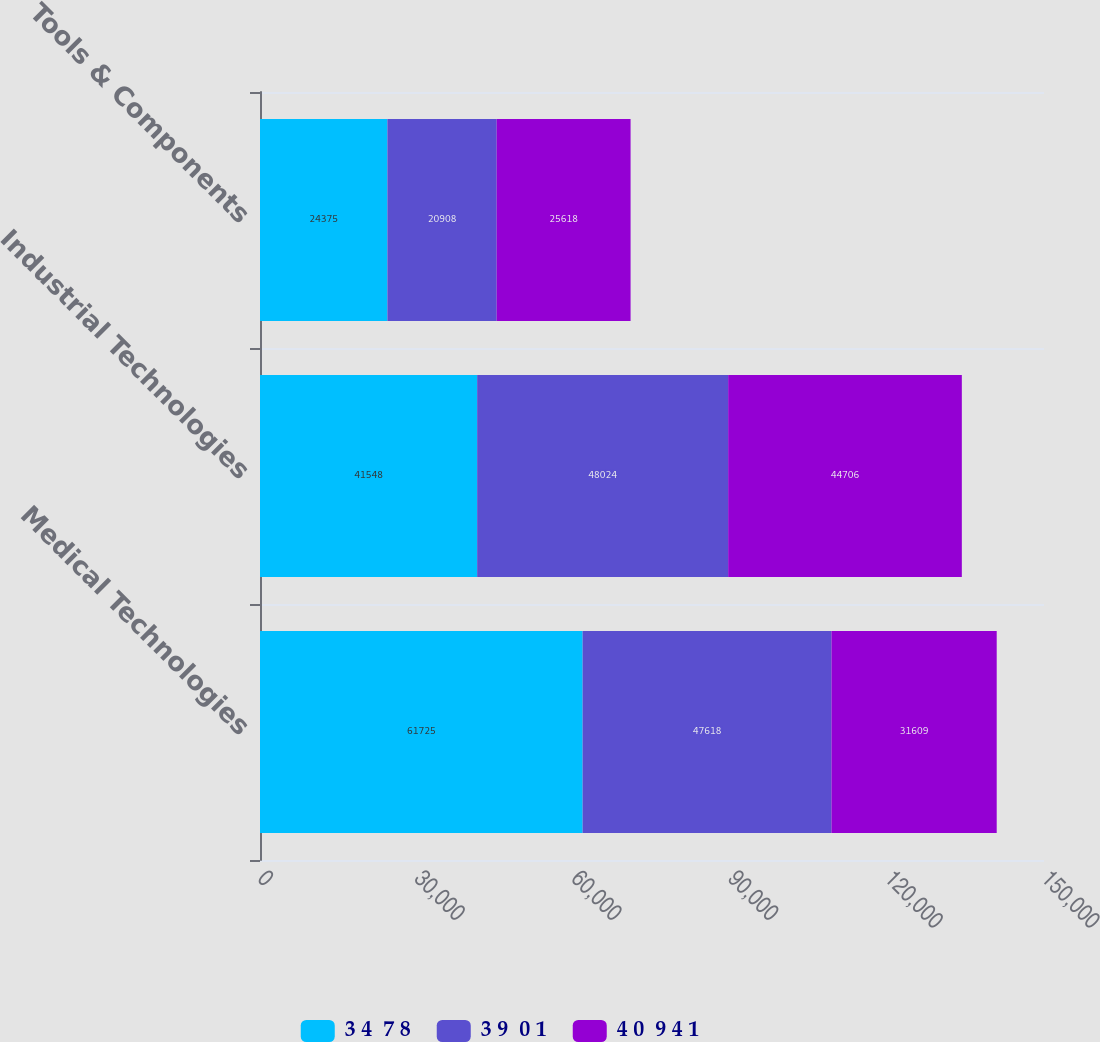<chart> <loc_0><loc_0><loc_500><loc_500><stacked_bar_chart><ecel><fcel>Medical Technologies<fcel>Industrial Technologies<fcel>Tools & Components<nl><fcel>3 4  7 8<fcel>61725<fcel>41548<fcel>24375<nl><fcel>3 9  0 1<fcel>47618<fcel>48024<fcel>20908<nl><fcel>4 0  9 4 1<fcel>31609<fcel>44706<fcel>25618<nl></chart> 